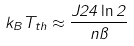Convert formula to latex. <formula><loc_0><loc_0><loc_500><loc_500>k _ { B } T _ { t h } \approx \frac { J 2 4 \ln 2 } { n \pi } \,</formula> 